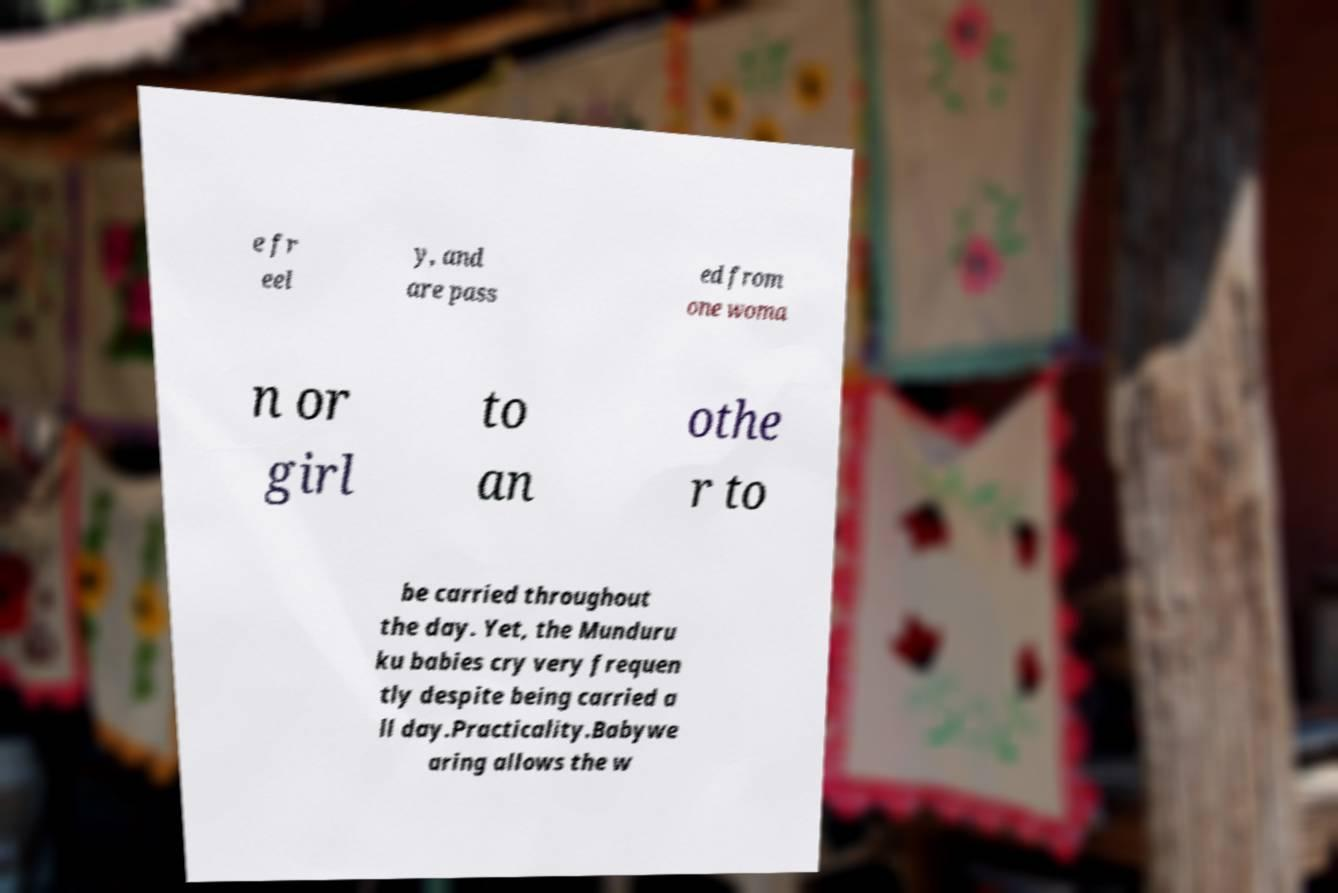Please read and relay the text visible in this image. What does it say? e fr eel y, and are pass ed from one woma n or girl to an othe r to be carried throughout the day. Yet, the Munduru ku babies cry very frequen tly despite being carried a ll day.Practicality.Babywe aring allows the w 